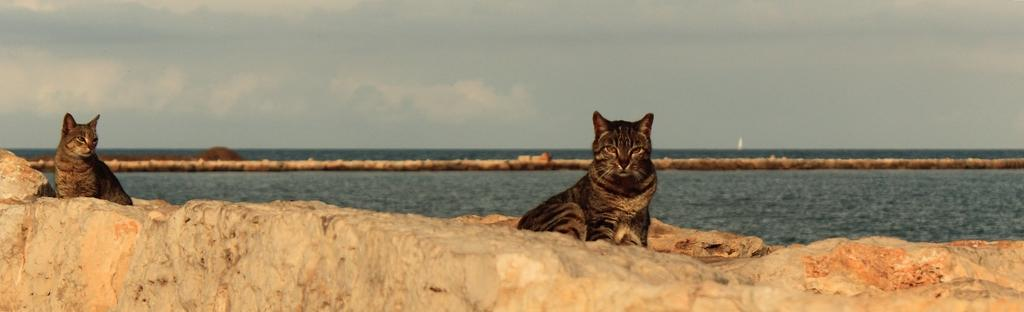What is the main subject in the image? There is a huge rock in the image. Can you describe the color of the rock? The rock is cream, orange, and brown in color. What animals are present on the rock? There are two cats on the rock. What can be seen in the distance in the image? There is water, the ground, and the sky visible in the background of the image. Are there any dinosaurs visible in the image? No, there are no dinosaurs present in the image. What type of pan is being used to cook the cats in the image? There is no pan or cooking activity depicted in the image; it features a rock with two cats on it. 